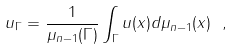Convert formula to latex. <formula><loc_0><loc_0><loc_500><loc_500>u _ { \Gamma } = \frac { 1 } { \mu _ { n - 1 } ( \Gamma ) } \int _ { \Gamma } u ( x ) d \mu _ { n - 1 } ( x ) \ ,</formula> 